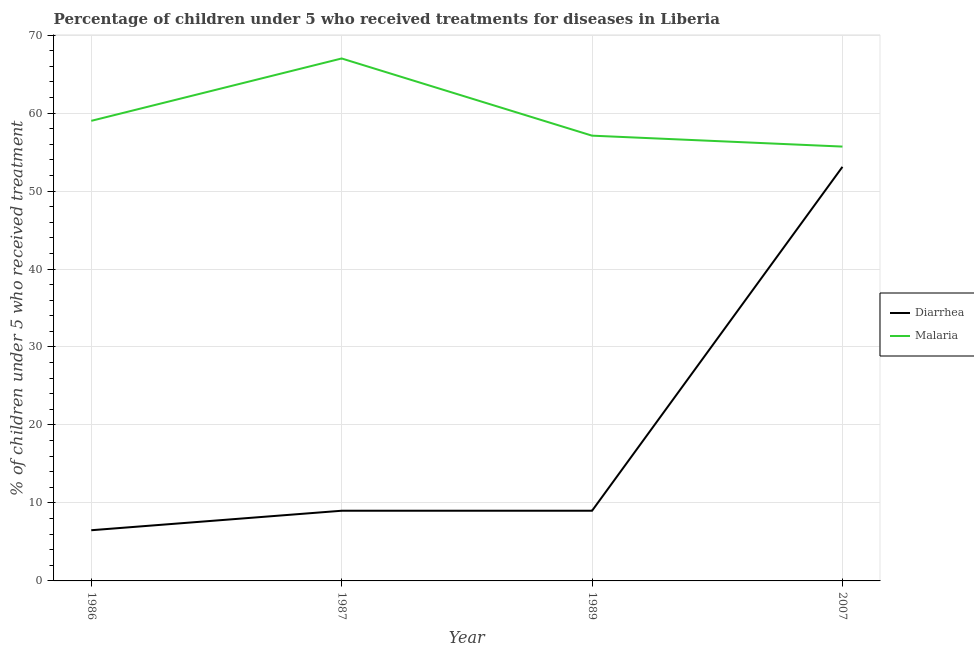What is the percentage of children who received treatment for diarrhoea in 1987?
Offer a very short reply. 9. Across all years, what is the maximum percentage of children who received treatment for malaria?
Provide a short and direct response. 67. What is the total percentage of children who received treatment for malaria in the graph?
Offer a very short reply. 238.8. What is the difference between the percentage of children who received treatment for malaria in 1987 and that in 2007?
Your answer should be very brief. 11.3. What is the difference between the percentage of children who received treatment for diarrhoea in 2007 and the percentage of children who received treatment for malaria in 1987?
Offer a very short reply. -13.9. What is the average percentage of children who received treatment for diarrhoea per year?
Provide a succinct answer. 19.4. In the year 1987, what is the difference between the percentage of children who received treatment for malaria and percentage of children who received treatment for diarrhoea?
Your answer should be very brief. 58. In how many years, is the percentage of children who received treatment for diarrhoea greater than 22 %?
Ensure brevity in your answer.  1. What is the ratio of the percentage of children who received treatment for diarrhoea in 1986 to that in 2007?
Ensure brevity in your answer.  0.12. Is the percentage of children who received treatment for diarrhoea in 1986 less than that in 1989?
Your response must be concise. Yes. What is the difference between the highest and the second highest percentage of children who received treatment for diarrhoea?
Ensure brevity in your answer.  44.1. What is the difference between the highest and the lowest percentage of children who received treatment for malaria?
Your answer should be very brief. 11.3. In how many years, is the percentage of children who received treatment for malaria greater than the average percentage of children who received treatment for malaria taken over all years?
Make the answer very short. 1. Is the percentage of children who received treatment for malaria strictly greater than the percentage of children who received treatment for diarrhoea over the years?
Ensure brevity in your answer.  Yes. Is the percentage of children who received treatment for diarrhoea strictly less than the percentage of children who received treatment for malaria over the years?
Your response must be concise. Yes. How many lines are there?
Give a very brief answer. 2. Are the values on the major ticks of Y-axis written in scientific E-notation?
Provide a short and direct response. No. Does the graph contain any zero values?
Your answer should be compact. No. What is the title of the graph?
Your answer should be compact. Percentage of children under 5 who received treatments for diseases in Liberia. What is the label or title of the Y-axis?
Your response must be concise. % of children under 5 who received treatment. What is the % of children under 5 who received treatment of Diarrhea in 1986?
Give a very brief answer. 6.5. What is the % of children under 5 who received treatment of Malaria in 1989?
Ensure brevity in your answer.  57.1. What is the % of children under 5 who received treatment in Diarrhea in 2007?
Give a very brief answer. 53.1. What is the % of children under 5 who received treatment of Malaria in 2007?
Your answer should be very brief. 55.7. Across all years, what is the maximum % of children under 5 who received treatment of Diarrhea?
Your response must be concise. 53.1. Across all years, what is the minimum % of children under 5 who received treatment of Diarrhea?
Your answer should be very brief. 6.5. Across all years, what is the minimum % of children under 5 who received treatment of Malaria?
Ensure brevity in your answer.  55.7. What is the total % of children under 5 who received treatment of Diarrhea in the graph?
Your answer should be compact. 77.6. What is the total % of children under 5 who received treatment in Malaria in the graph?
Your answer should be compact. 238.8. What is the difference between the % of children under 5 who received treatment in Diarrhea in 1986 and that in 1987?
Provide a short and direct response. -2.5. What is the difference between the % of children under 5 who received treatment in Diarrhea in 1986 and that in 1989?
Your response must be concise. -2.5. What is the difference between the % of children under 5 who received treatment in Malaria in 1986 and that in 1989?
Your response must be concise. 1.9. What is the difference between the % of children under 5 who received treatment in Diarrhea in 1986 and that in 2007?
Ensure brevity in your answer.  -46.6. What is the difference between the % of children under 5 who received treatment in Malaria in 1986 and that in 2007?
Keep it short and to the point. 3.3. What is the difference between the % of children under 5 who received treatment of Diarrhea in 1987 and that in 2007?
Offer a terse response. -44.1. What is the difference between the % of children under 5 who received treatment of Diarrhea in 1989 and that in 2007?
Offer a very short reply. -44.1. What is the difference between the % of children under 5 who received treatment in Malaria in 1989 and that in 2007?
Your answer should be compact. 1.4. What is the difference between the % of children under 5 who received treatment in Diarrhea in 1986 and the % of children under 5 who received treatment in Malaria in 1987?
Your answer should be very brief. -60.5. What is the difference between the % of children under 5 who received treatment of Diarrhea in 1986 and the % of children under 5 who received treatment of Malaria in 1989?
Give a very brief answer. -50.6. What is the difference between the % of children under 5 who received treatment of Diarrhea in 1986 and the % of children under 5 who received treatment of Malaria in 2007?
Offer a terse response. -49.2. What is the difference between the % of children under 5 who received treatment in Diarrhea in 1987 and the % of children under 5 who received treatment in Malaria in 1989?
Your answer should be very brief. -48.1. What is the difference between the % of children under 5 who received treatment in Diarrhea in 1987 and the % of children under 5 who received treatment in Malaria in 2007?
Your answer should be compact. -46.7. What is the difference between the % of children under 5 who received treatment in Diarrhea in 1989 and the % of children under 5 who received treatment in Malaria in 2007?
Your response must be concise. -46.7. What is the average % of children under 5 who received treatment of Diarrhea per year?
Your response must be concise. 19.4. What is the average % of children under 5 who received treatment of Malaria per year?
Keep it short and to the point. 59.7. In the year 1986, what is the difference between the % of children under 5 who received treatment in Diarrhea and % of children under 5 who received treatment in Malaria?
Your answer should be compact. -52.5. In the year 1987, what is the difference between the % of children under 5 who received treatment of Diarrhea and % of children under 5 who received treatment of Malaria?
Offer a terse response. -58. In the year 1989, what is the difference between the % of children under 5 who received treatment of Diarrhea and % of children under 5 who received treatment of Malaria?
Keep it short and to the point. -48.1. What is the ratio of the % of children under 5 who received treatment of Diarrhea in 1986 to that in 1987?
Offer a terse response. 0.72. What is the ratio of the % of children under 5 who received treatment in Malaria in 1986 to that in 1987?
Provide a short and direct response. 0.88. What is the ratio of the % of children under 5 who received treatment in Diarrhea in 1986 to that in 1989?
Provide a succinct answer. 0.72. What is the ratio of the % of children under 5 who received treatment in Malaria in 1986 to that in 1989?
Your answer should be very brief. 1.03. What is the ratio of the % of children under 5 who received treatment of Diarrhea in 1986 to that in 2007?
Give a very brief answer. 0.12. What is the ratio of the % of children under 5 who received treatment in Malaria in 1986 to that in 2007?
Ensure brevity in your answer.  1.06. What is the ratio of the % of children under 5 who received treatment in Diarrhea in 1987 to that in 1989?
Ensure brevity in your answer.  1. What is the ratio of the % of children under 5 who received treatment of Malaria in 1987 to that in 1989?
Provide a short and direct response. 1.17. What is the ratio of the % of children under 5 who received treatment of Diarrhea in 1987 to that in 2007?
Keep it short and to the point. 0.17. What is the ratio of the % of children under 5 who received treatment of Malaria in 1987 to that in 2007?
Offer a terse response. 1.2. What is the ratio of the % of children under 5 who received treatment of Diarrhea in 1989 to that in 2007?
Your response must be concise. 0.17. What is the ratio of the % of children under 5 who received treatment in Malaria in 1989 to that in 2007?
Your answer should be compact. 1.03. What is the difference between the highest and the second highest % of children under 5 who received treatment of Diarrhea?
Provide a short and direct response. 44.1. What is the difference between the highest and the lowest % of children under 5 who received treatment in Diarrhea?
Your response must be concise. 46.6. What is the difference between the highest and the lowest % of children under 5 who received treatment in Malaria?
Provide a succinct answer. 11.3. 